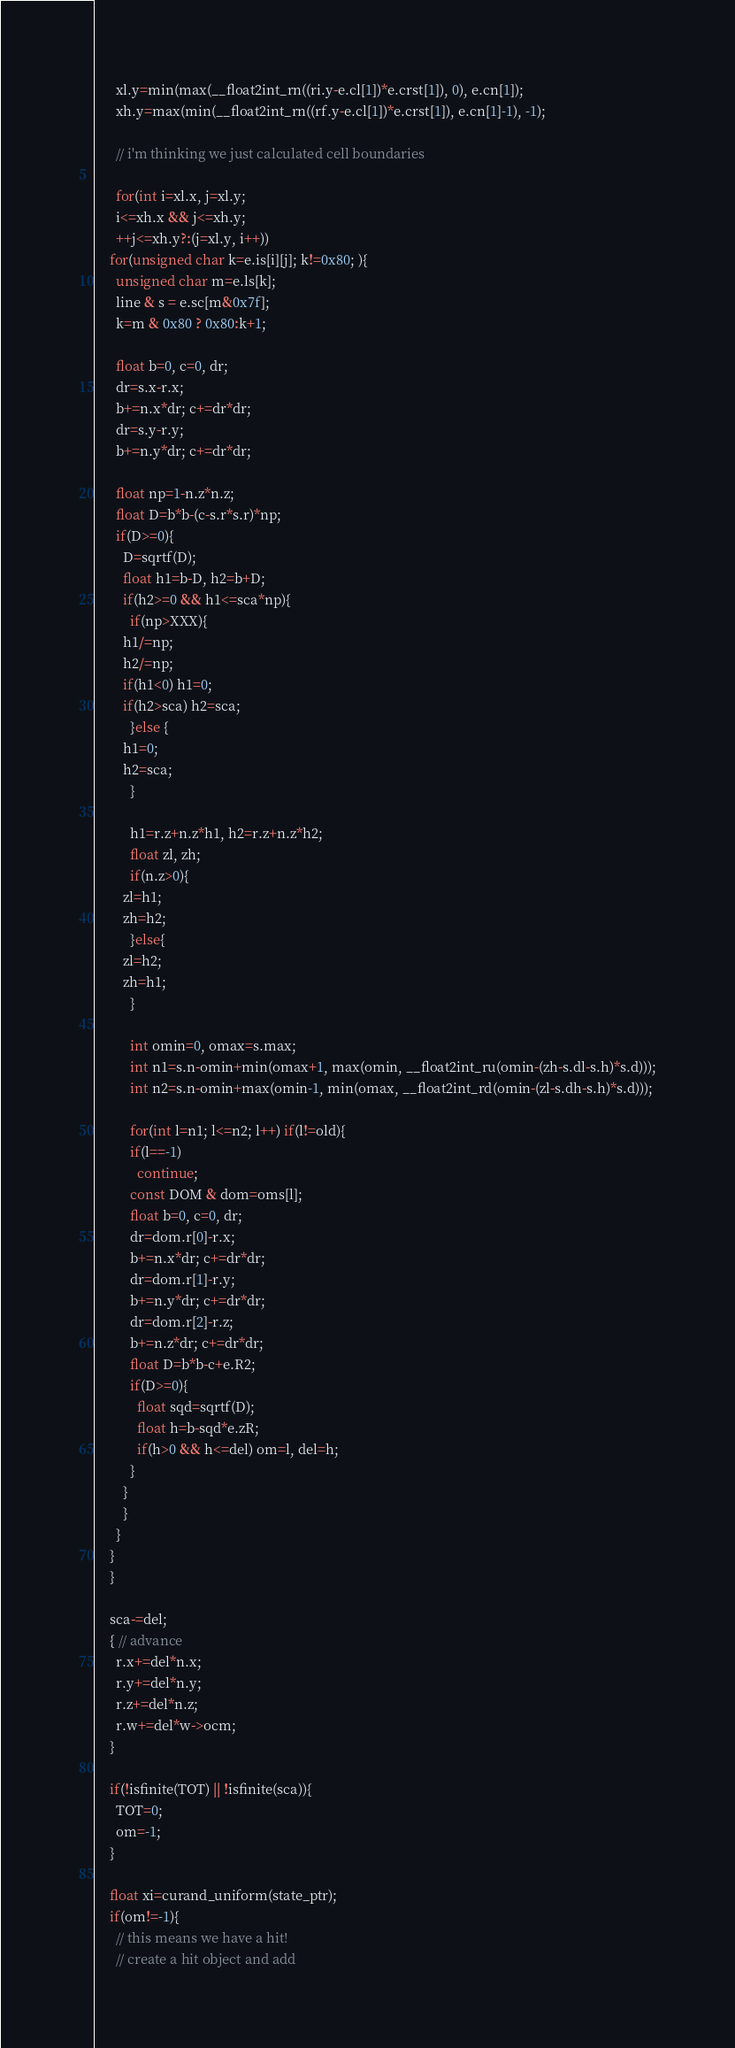<code> <loc_0><loc_0><loc_500><loc_500><_Cuda_>
      xl.y=min(max(__float2int_rn((ri.y-e.cl[1])*e.crst[1]), 0), e.cn[1]);
      xh.y=max(min(__float2int_rn((rf.y-e.cl[1])*e.crst[1]), e.cn[1]-1), -1);

      // i'm thinking we just calculated cell boundaries
      
      for(int i=xl.x, j=xl.y;
	  i<=xh.x && j<=xh.y;
	  ++j<=xh.y?:(j=xl.y, i++))
	for(unsigned char k=e.is[i][j]; k!=0x80; ){
	  unsigned char m=e.ls[k];
	  line & s = e.sc[m&0x7f];
	  k=m & 0x80 ? 0x80:k+1;

	  float b=0, c=0, dr;
	  dr=s.x-r.x;
	  b+=n.x*dr; c+=dr*dr;
	  dr=s.y-r.y;
	  b+=n.y*dr; c+=dr*dr;

	  float np=1-n.z*n.z;
	  float D=b*b-(c-s.r*s.r)*np;
	  if(D>=0){
	    D=sqrtf(D);
	    float h1=b-D, h2=b+D;
	    if(h2>=0 && h1<=sca*np){
	      if(np>XXX){
		h1/=np;
		h2/=np;
		if(h1<0) h1=0;
		if(h2>sca) h2=sca;
	      }else {
		h1=0;
		h2=sca;
	      }
	      
	      h1=r.z+n.z*h1, h2=r.z+n.z*h2;
	      float zl, zh;
	      if(n.z>0){
		zl=h1;
		zh=h2;
	      }else{
		zl=h2;
		zh=h1;
	      }

	      int omin=0, omax=s.max;
	      int n1=s.n-omin+min(omax+1, max(omin, __float2int_ru(omin-(zh-s.dl-s.h)*s.d)));
	      int n2=s.n-omin+max(omin-1, min(omax, __float2int_rd(omin-(zl-s.dh-s.h)*s.d)));
	      
	      for(int l=n1; l<=n2; l++) if(l!=old){
		  if(l==-1) 
		    continue;
		  const DOM & dom=oms[l];
		  float b=0, c=0, dr;
		  dr=dom.r[0]-r.x;
		  b+=n.x*dr; c+=dr*dr;
		  dr=dom.r[1]-r.y;
		  b+=n.y*dr; c+=dr*dr;
		  dr=dom.r[2]-r.z;
		  b+=n.z*dr; c+=dr*dr;
		  float D=b*b-c+e.R2;
		  if(D>=0){
		    float sqd=sqrtf(D);
		    float h=b-sqd*e.zR;
		    if(h>0 && h<=del) om=l, del=h;
		  }
		}
	    }
	  }
	}
    }
    
    sca-=del;
    { // advance
      r.x+=del*n.x;
      r.y+=del*n.y;
      r.z+=del*n.z;
      r.w+=del*w->ocm;
    }

    if(!isfinite(TOT) || !isfinite(sca)){
      TOT=0;
      om=-1;
    }

    float xi=curand_uniform(state_ptr);
    if(om!=-1){
      // this means we have a hit!
      // create a hit object and add</code> 